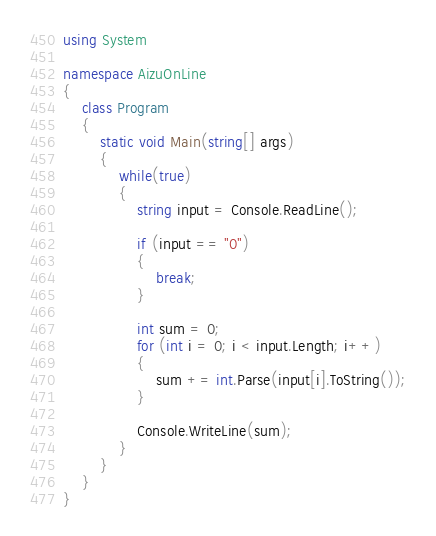Convert code to text. <code><loc_0><loc_0><loc_500><loc_500><_C#_>using System

namespace AizuOnLine
{
    class Program
    {
        static void Main(string[] args)
        {
            while(true)
            {
                string input = Console.ReadLine();

                if (input == "0")
                {
                    break;
                }

                int sum = 0;
                for (int i = 0; i < input.Length; i++)
                {
                    sum += int.Parse(input[i].ToString());
                }

                Console.WriteLine(sum);
            }
        }
    }
}</code> 